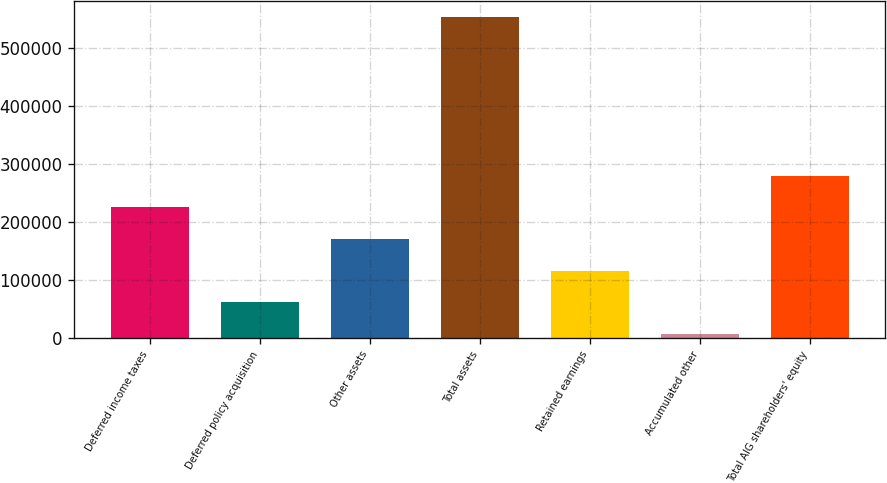<chart> <loc_0><loc_0><loc_500><loc_500><bar_chart><fcel>Deferred income taxes<fcel>Deferred policy acquisition<fcel>Other assets<fcel>Total assets<fcel>Retained earnings<fcel>Accumulated other<fcel>Total AIG shareholders' equity<nl><fcel>225110<fcel>61138.3<fcel>170453<fcel>553054<fcel>115796<fcel>6481<fcel>279768<nl></chart> 